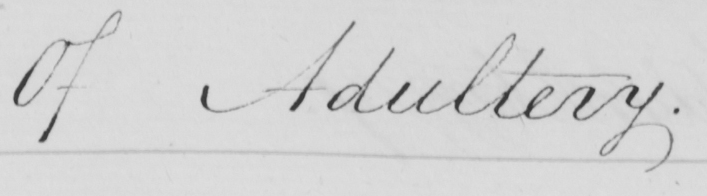Please transcribe the handwritten text in this image. Of Adultery . 